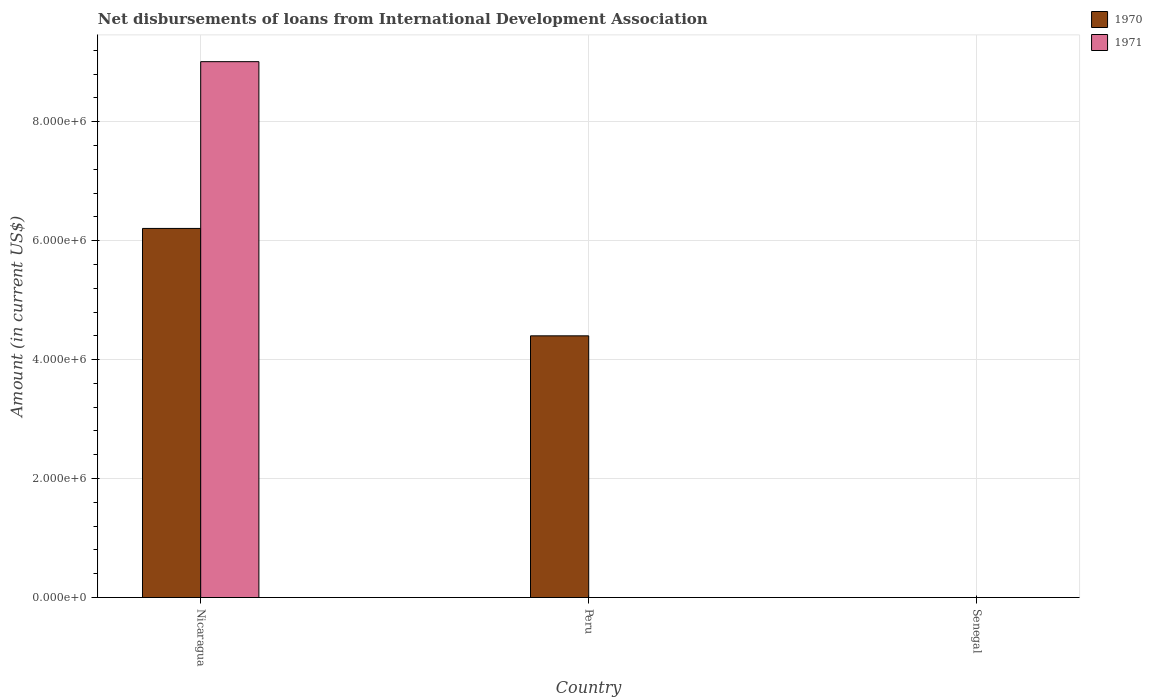Are the number of bars per tick equal to the number of legend labels?
Keep it short and to the point. No. How many bars are there on the 2nd tick from the right?
Offer a terse response. 1. What is the label of the 3rd group of bars from the left?
Provide a succinct answer. Senegal. In how many cases, is the number of bars for a given country not equal to the number of legend labels?
Your answer should be compact. 2. What is the amount of loans disbursed in 1970 in Nicaragua?
Provide a short and direct response. 6.21e+06. Across all countries, what is the maximum amount of loans disbursed in 1971?
Your answer should be very brief. 9.01e+06. Across all countries, what is the minimum amount of loans disbursed in 1971?
Give a very brief answer. 0. In which country was the amount of loans disbursed in 1970 maximum?
Offer a very short reply. Nicaragua. What is the total amount of loans disbursed in 1971 in the graph?
Make the answer very short. 9.01e+06. What is the difference between the amount of loans disbursed in 1970 in Nicaragua and that in Peru?
Offer a very short reply. 1.81e+06. What is the difference between the amount of loans disbursed in 1970 in Senegal and the amount of loans disbursed in 1971 in Peru?
Offer a very short reply. 0. What is the average amount of loans disbursed in 1970 per country?
Give a very brief answer. 3.54e+06. What is the difference between the amount of loans disbursed of/in 1971 and amount of loans disbursed of/in 1970 in Nicaragua?
Make the answer very short. 2.80e+06. What is the difference between the highest and the lowest amount of loans disbursed in 1970?
Make the answer very short. 6.21e+06. How many bars are there?
Your answer should be compact. 3. What is the difference between two consecutive major ticks on the Y-axis?
Your answer should be very brief. 2.00e+06. Does the graph contain grids?
Provide a short and direct response. Yes. How many legend labels are there?
Your answer should be very brief. 2. How are the legend labels stacked?
Your answer should be very brief. Vertical. What is the title of the graph?
Keep it short and to the point. Net disbursements of loans from International Development Association. Does "1966" appear as one of the legend labels in the graph?
Give a very brief answer. No. What is the Amount (in current US$) in 1970 in Nicaragua?
Offer a very short reply. 6.21e+06. What is the Amount (in current US$) in 1971 in Nicaragua?
Offer a terse response. 9.01e+06. What is the Amount (in current US$) in 1970 in Peru?
Provide a succinct answer. 4.40e+06. What is the Amount (in current US$) of 1971 in Peru?
Your response must be concise. 0. What is the Amount (in current US$) in 1971 in Senegal?
Offer a terse response. 0. Across all countries, what is the maximum Amount (in current US$) in 1970?
Provide a succinct answer. 6.21e+06. Across all countries, what is the maximum Amount (in current US$) in 1971?
Provide a succinct answer. 9.01e+06. Across all countries, what is the minimum Amount (in current US$) of 1971?
Make the answer very short. 0. What is the total Amount (in current US$) in 1970 in the graph?
Offer a terse response. 1.06e+07. What is the total Amount (in current US$) of 1971 in the graph?
Offer a terse response. 9.01e+06. What is the difference between the Amount (in current US$) of 1970 in Nicaragua and that in Peru?
Your answer should be compact. 1.81e+06. What is the average Amount (in current US$) of 1970 per country?
Keep it short and to the point. 3.54e+06. What is the average Amount (in current US$) of 1971 per country?
Provide a succinct answer. 3.00e+06. What is the difference between the Amount (in current US$) in 1970 and Amount (in current US$) in 1971 in Nicaragua?
Give a very brief answer. -2.80e+06. What is the ratio of the Amount (in current US$) in 1970 in Nicaragua to that in Peru?
Your response must be concise. 1.41. What is the difference between the highest and the lowest Amount (in current US$) in 1970?
Give a very brief answer. 6.21e+06. What is the difference between the highest and the lowest Amount (in current US$) of 1971?
Give a very brief answer. 9.01e+06. 